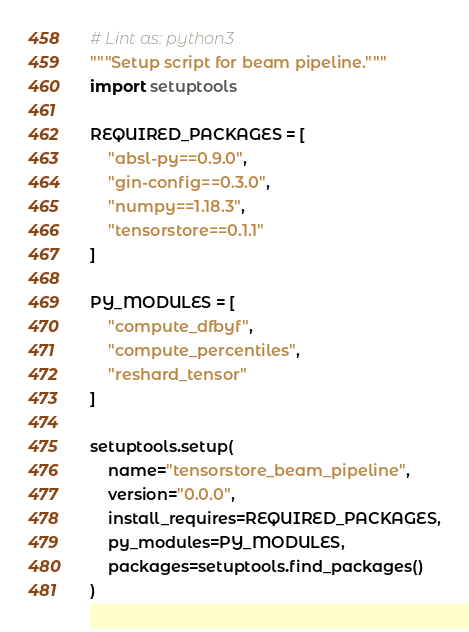Convert code to text. <code><loc_0><loc_0><loc_500><loc_500><_Python_># Lint as: python3
"""Setup script for beam pipeline."""
import setuptools

REQUIRED_PACKAGES = [
    "absl-py==0.9.0",
    "gin-config==0.3.0",
    "numpy==1.18.3",
    "tensorstore==0.1.1"
]

PY_MODULES = [
    "compute_dfbyf",
    "compute_percentiles",
    "reshard_tensor"
]

setuptools.setup(
    name="tensorstore_beam_pipeline",
    version="0.0.0",
    install_requires=REQUIRED_PACKAGES,
    py_modules=PY_MODULES,
    packages=setuptools.find_packages()
)
</code> 